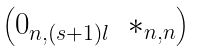<formula> <loc_0><loc_0><loc_500><loc_500>\begin{pmatrix} 0 _ { n , ( s + 1 ) l } & * _ { n , n } \end{pmatrix}</formula> 